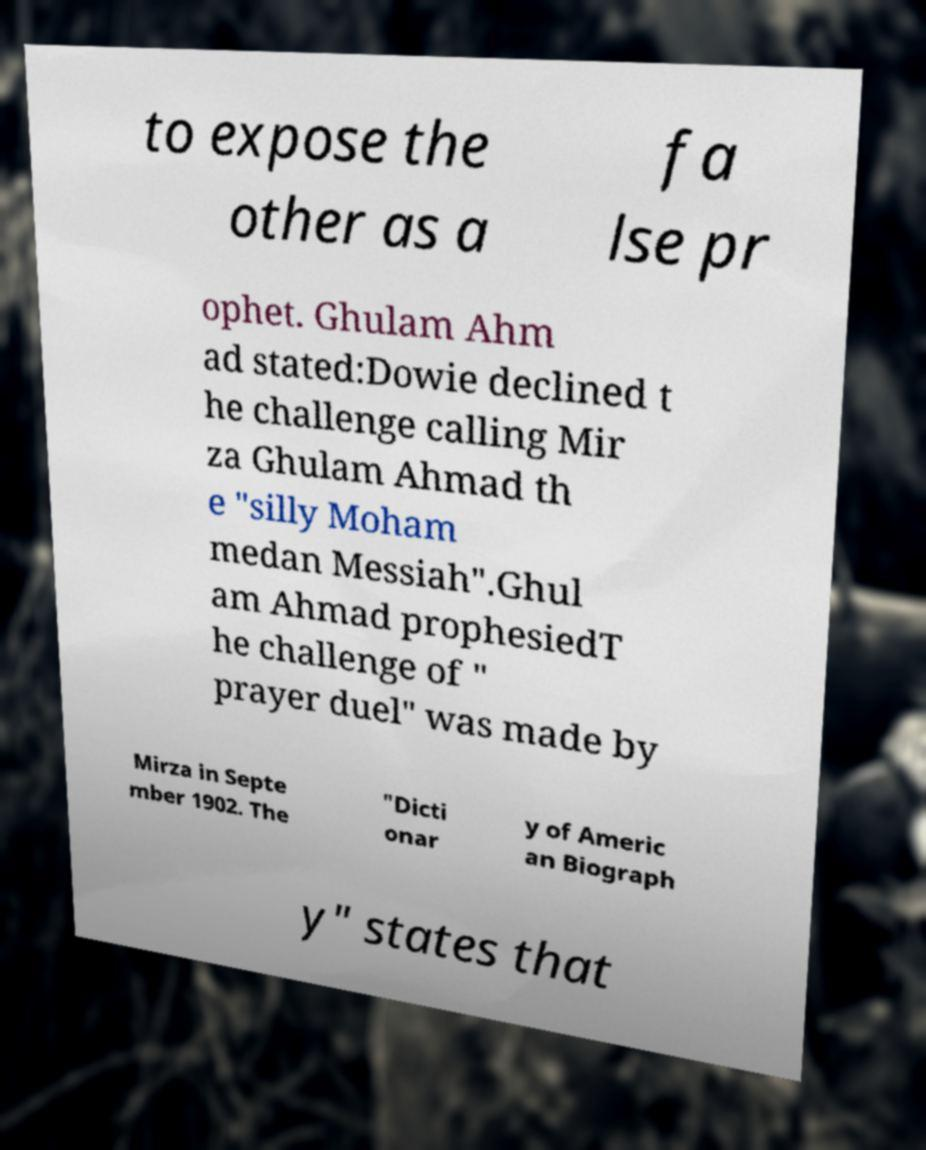Could you assist in decoding the text presented in this image and type it out clearly? to expose the other as a fa lse pr ophet. Ghulam Ahm ad stated:Dowie declined t he challenge calling Mir za Ghulam Ahmad th e "silly Moham medan Messiah".Ghul am Ahmad prophesiedT he challenge of " prayer duel" was made by Mirza in Septe mber 1902. The "Dicti onar y of Americ an Biograph y" states that 